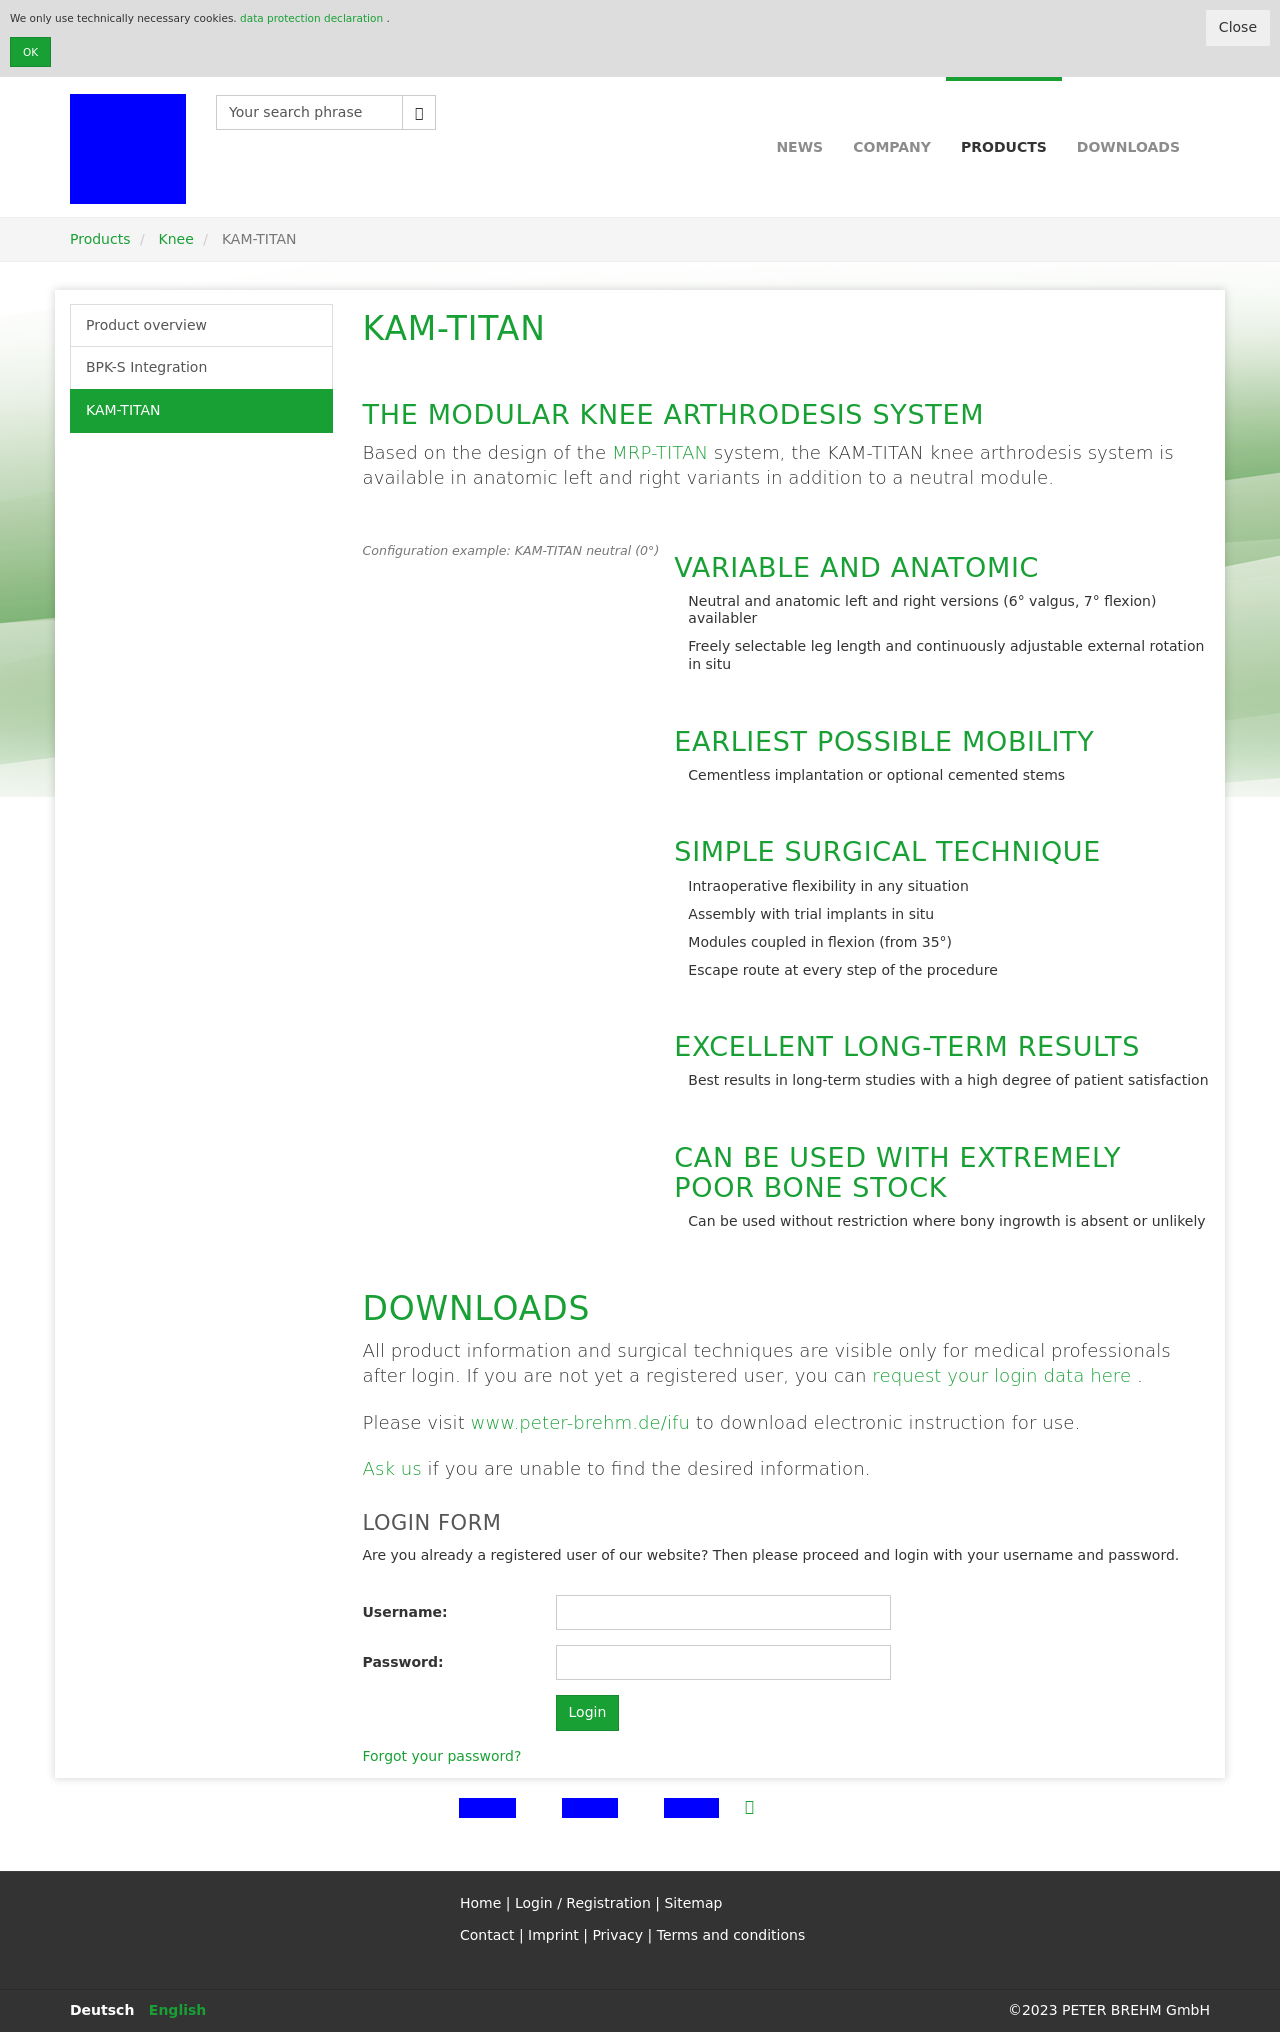What specific features are highlighted in the image about the KAM-TITAN knee system? The image highlights several features of the KAM-TITAN knee system, such as its modular design, its options for neutral and anatomic left/right versions, and its adaptability with freely selectable leg lengths and adjustable external rotation in situ. These characteristics emphasize its versatility and capability to provide customized solutions for knee arthrodesis. 